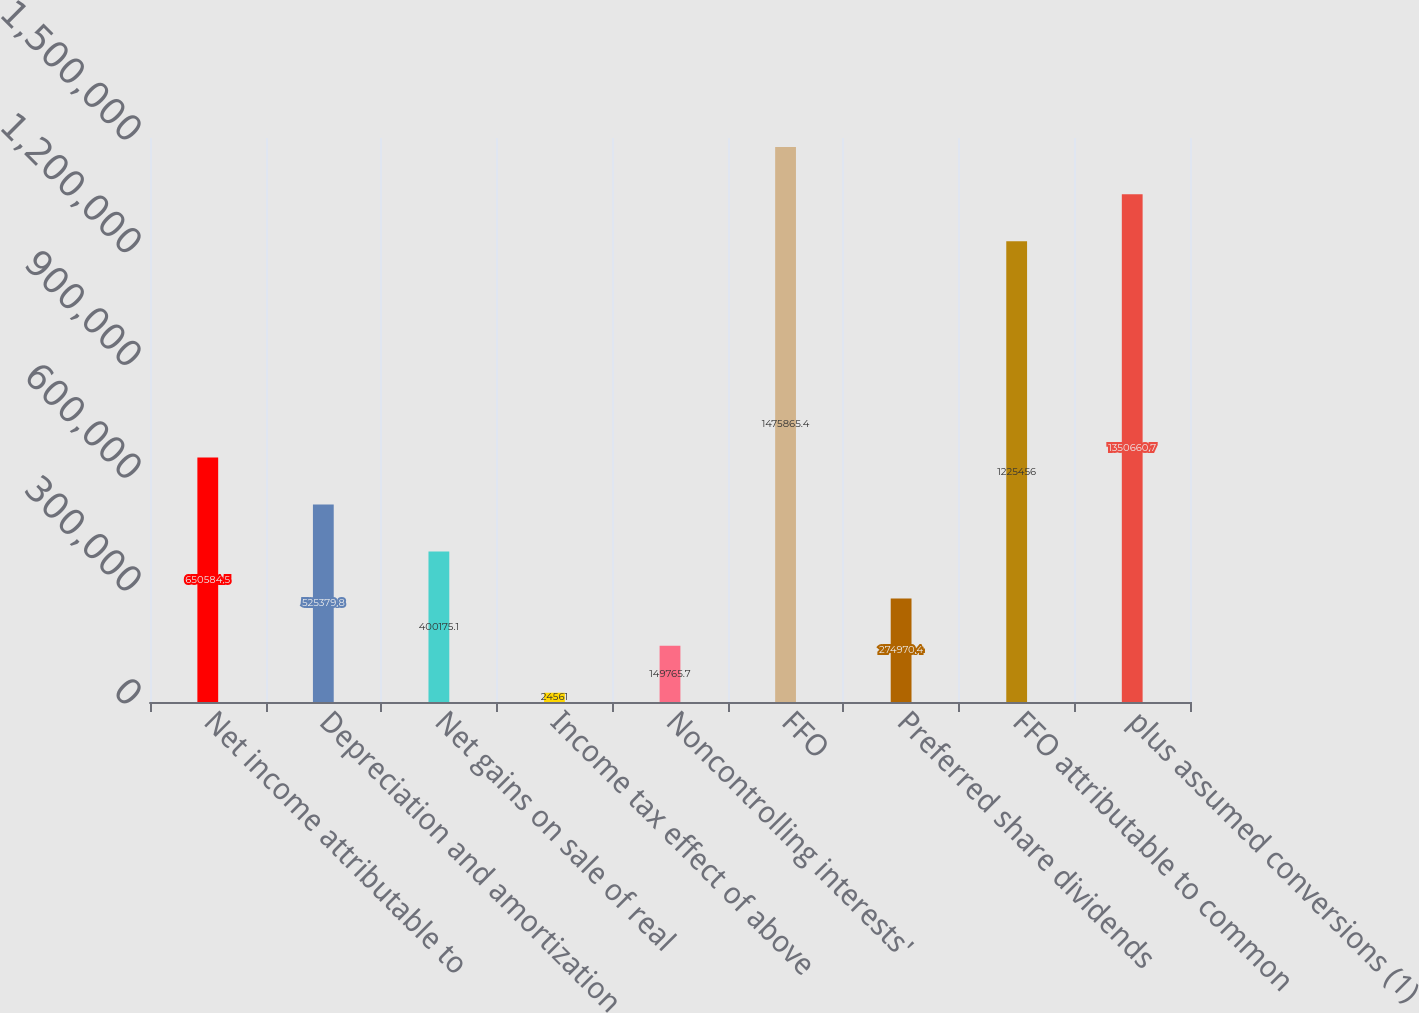Convert chart. <chart><loc_0><loc_0><loc_500><loc_500><bar_chart><fcel>Net income attributable to<fcel>Depreciation and amortization<fcel>Net gains on sale of real<fcel>Income tax effect of above<fcel>Noncontrolling interests'<fcel>FFO<fcel>Preferred share dividends<fcel>FFO attributable to common<fcel>plus assumed conversions (1)<nl><fcel>650584<fcel>525380<fcel>400175<fcel>24561<fcel>149766<fcel>1.47587e+06<fcel>274970<fcel>1.22546e+06<fcel>1.35066e+06<nl></chart> 